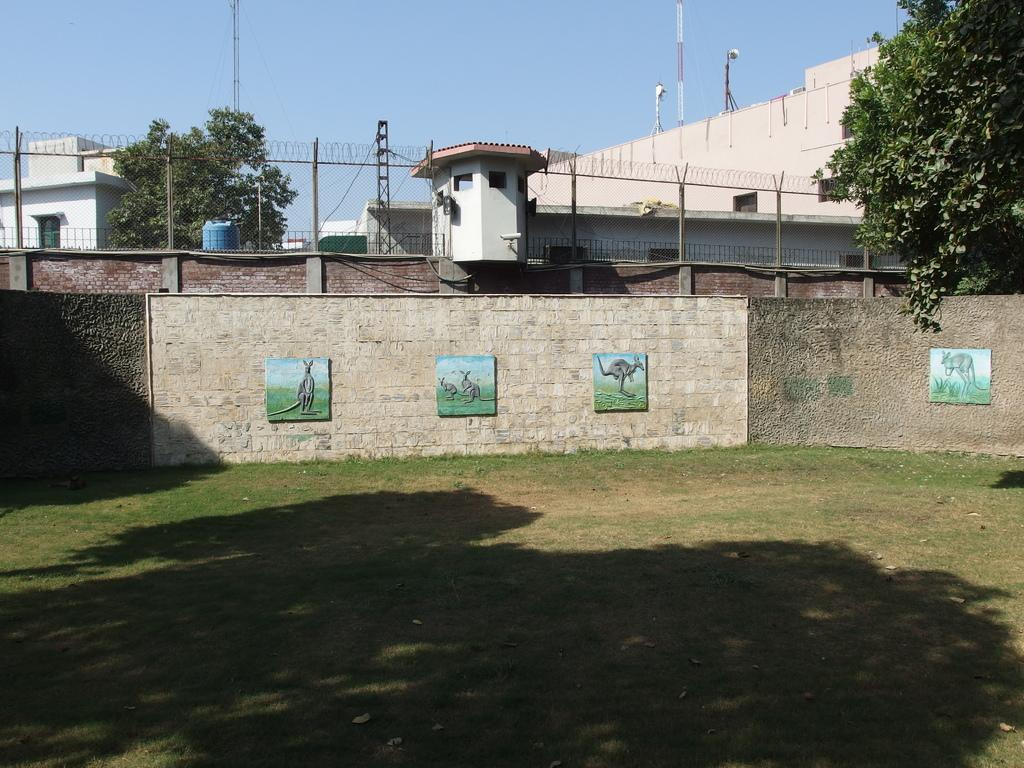What type of natural elements can be seen in the image? There are trees in the image. What type of man-made structures are visible in the image? There are buildings and towers in the image. What type of infrastructure can be seen in the image? There are poles with wires in the image. What type of decorative elements are present in the image? There are frames placed on the wall in the image. What type of surface is visible at the bottom of the image? There is ground visible at the bottom of the image. What type of book is being read by the tree in the image? There is no book present in the image, and trees do not read books. What type of string is being used to hold up the towers in the image? There is no string present in the image, and the towers are not being held up by any visible strings. 